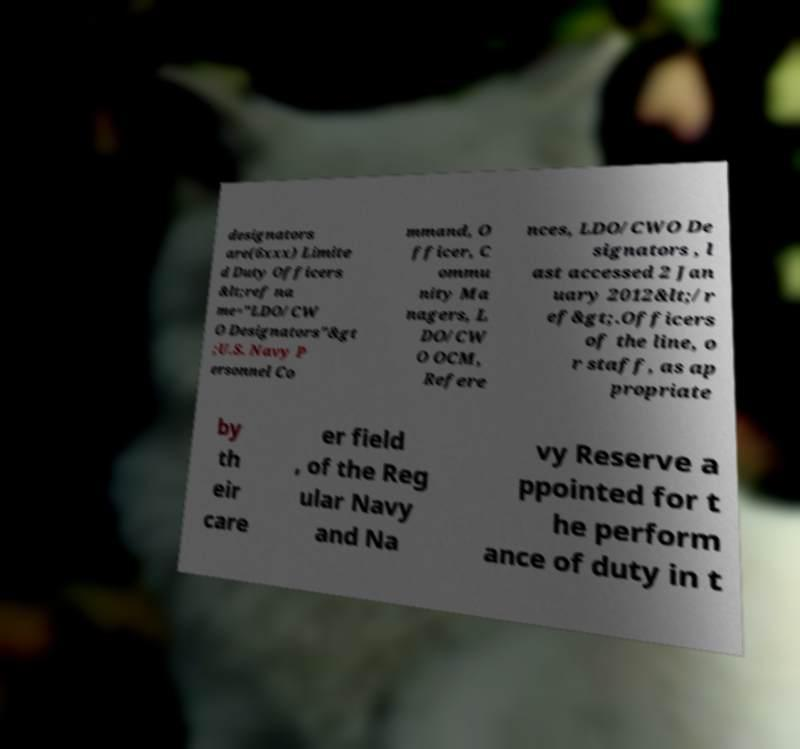Can you read and provide the text displayed in the image?This photo seems to have some interesting text. Can you extract and type it out for me? designators are(6xxx) Limite d Duty Officers &lt;ref na me="LDO/CW O Designators"&gt ;U.S. Navy P ersonnel Co mmand, O fficer, C ommu nity Ma nagers, L DO/CW O OCM, Refere nces, LDO/CWO De signators , l ast accessed 2 Jan uary 2012&lt;/r ef&gt;.Officers of the line, o r staff, as ap propriate by th eir care er field , of the Reg ular Navy and Na vy Reserve a ppointed for t he perform ance of duty in t 